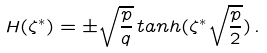Convert formula to latex. <formula><loc_0><loc_0><loc_500><loc_500>H ( \zeta ^ { * } ) = \pm \sqrt { \frac { p } { q } } \, t a n h ( \zeta ^ { * } \sqrt { \frac { p } { 2 } } ) \, .</formula> 